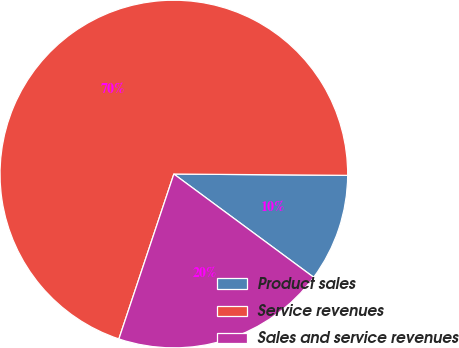<chart> <loc_0><loc_0><loc_500><loc_500><pie_chart><fcel>Product sales<fcel>Service revenues<fcel>Sales and service revenues<nl><fcel>10.0%<fcel>70.0%<fcel>20.0%<nl></chart> 